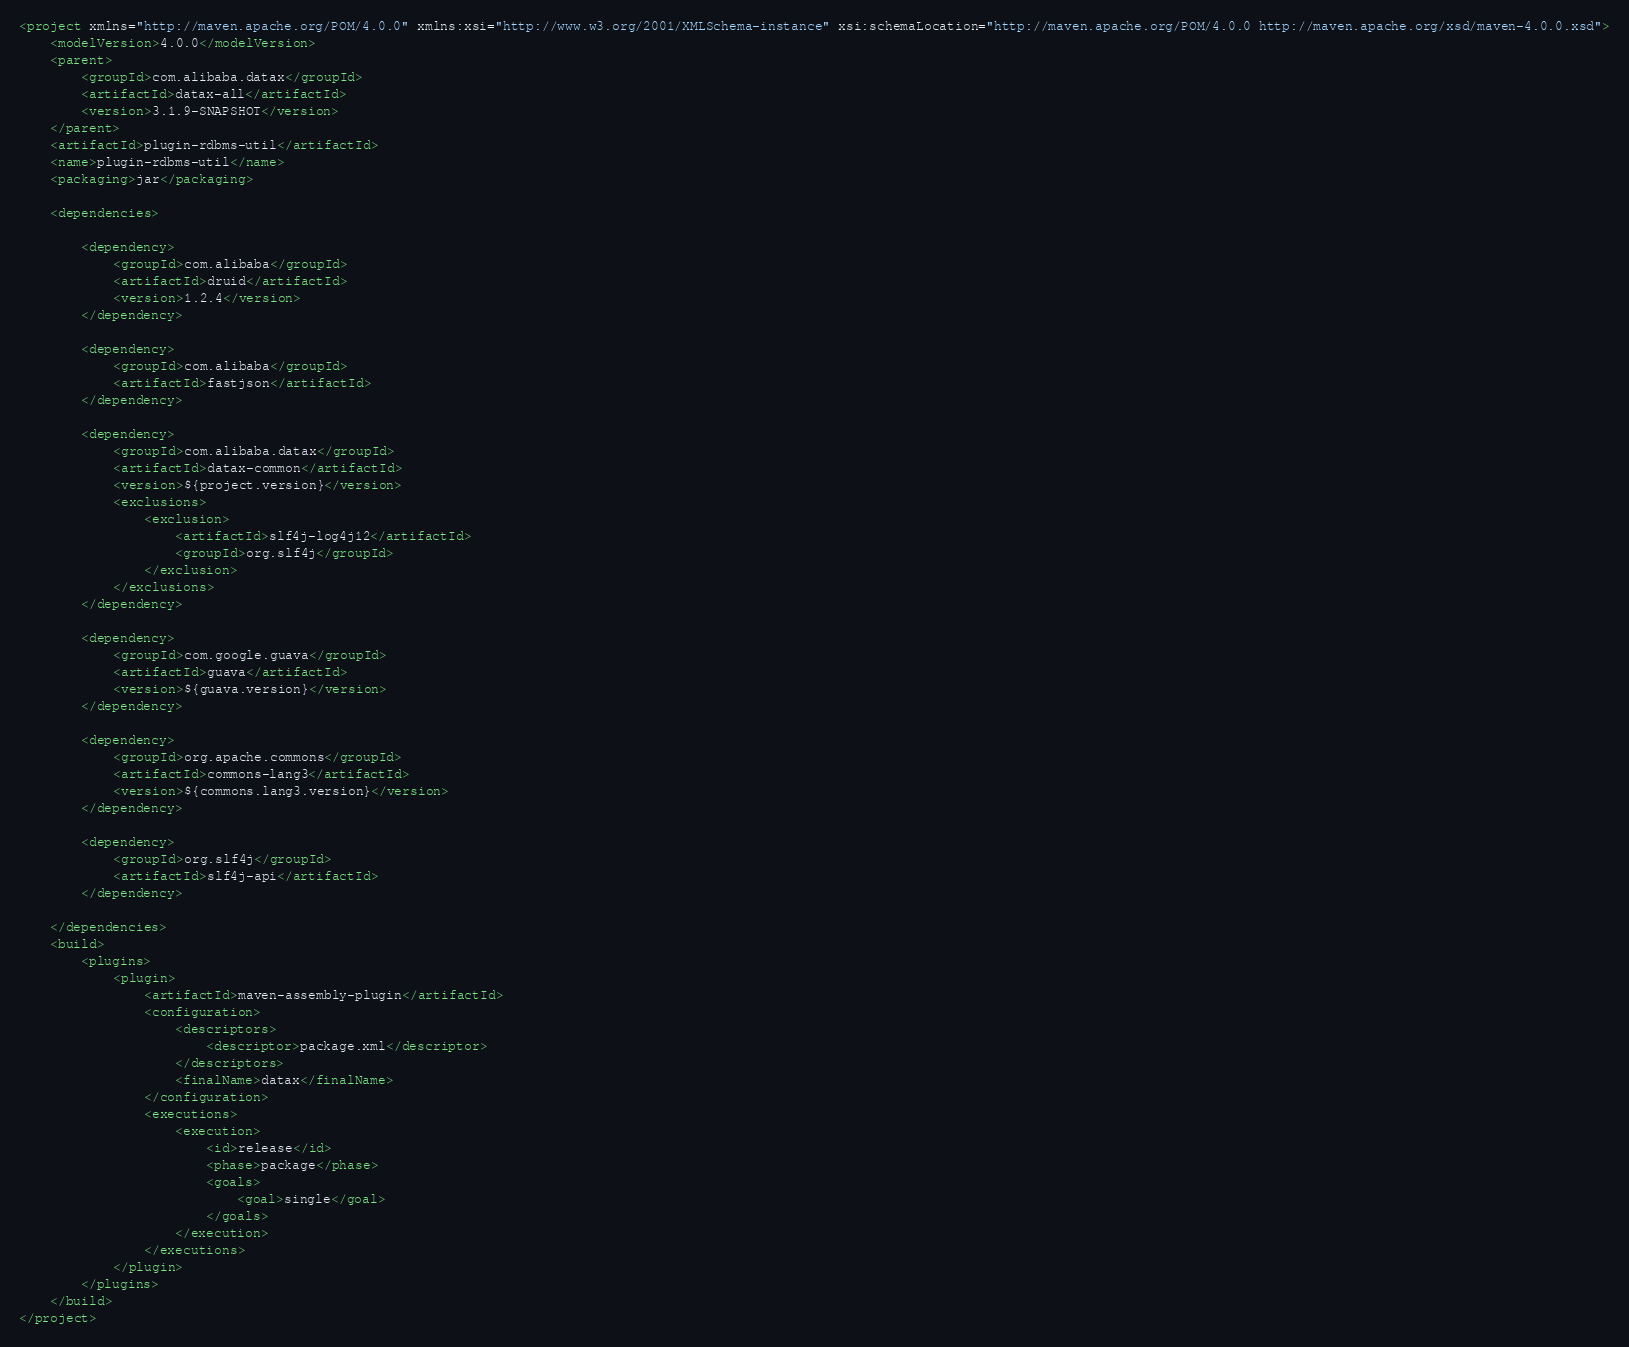<code> <loc_0><loc_0><loc_500><loc_500><_XML_><project xmlns="http://maven.apache.org/POM/4.0.0" xmlns:xsi="http://www.w3.org/2001/XMLSchema-instance" xsi:schemaLocation="http://maven.apache.org/POM/4.0.0 http://maven.apache.org/xsd/maven-4.0.0.xsd">
    <modelVersion>4.0.0</modelVersion>
    <parent>
        <groupId>com.alibaba.datax</groupId>
        <artifactId>datax-all</artifactId>
        <version>3.1.9-SNAPSHOT</version>
    </parent>
    <artifactId>plugin-rdbms-util</artifactId>
    <name>plugin-rdbms-util</name>
    <packaging>jar</packaging>

    <dependencies>

        <dependency>
            <groupId>com.alibaba</groupId>
            <artifactId>druid</artifactId>
            <version>1.2.4</version>
        </dependency>

        <dependency>
            <groupId>com.alibaba</groupId>
            <artifactId>fastjson</artifactId>
        </dependency>

        <dependency>
            <groupId>com.alibaba.datax</groupId>
            <artifactId>datax-common</artifactId>
            <version>${project.version}</version>
            <exclusions>
                <exclusion>
                    <artifactId>slf4j-log4j12</artifactId>
                    <groupId>org.slf4j</groupId>
                </exclusion>
            </exclusions>
        </dependency>

        <dependency>
            <groupId>com.google.guava</groupId>
            <artifactId>guava</artifactId>
            <version>${guava.version}</version>
        </dependency>

        <dependency>
            <groupId>org.apache.commons</groupId>
            <artifactId>commons-lang3</artifactId>
            <version>${commons.lang3.version}</version>
        </dependency>

        <dependency>
            <groupId>org.slf4j</groupId>
            <artifactId>slf4j-api</artifactId>
        </dependency>

    </dependencies>
    <build>
        <plugins>
            <plugin>
                <artifactId>maven-assembly-plugin</artifactId>
                <configuration>
                    <descriptors>
                        <descriptor>package.xml</descriptor>
                    </descriptors>
                    <finalName>datax</finalName>
                </configuration>
                <executions>
                    <execution>
                        <id>release</id>
                        <phase>package</phase>
                        <goals>
                            <goal>single</goal>
                        </goals>
                    </execution>
                </executions>
            </plugin>
        </plugins>
    </build>
</project>
</code> 